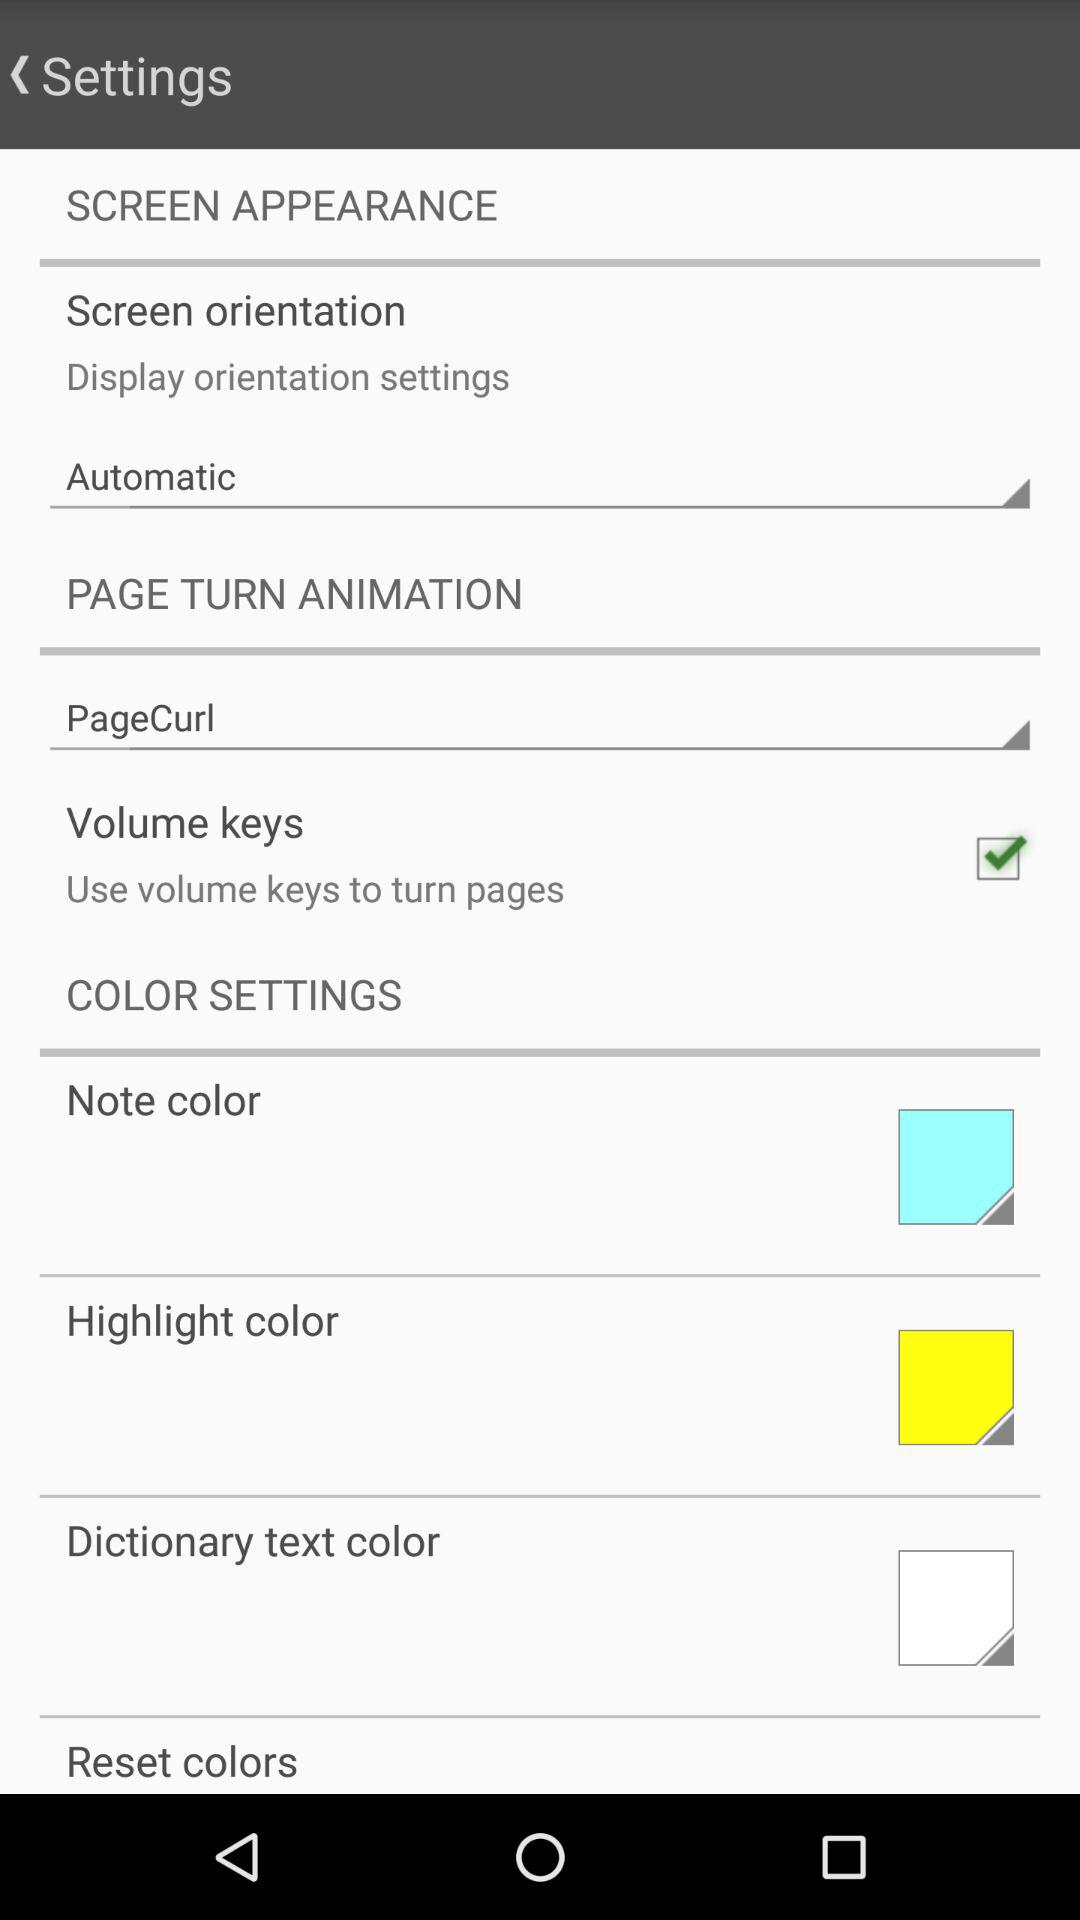What is the display orientation setting? The display orientation setting is "Automatic". 